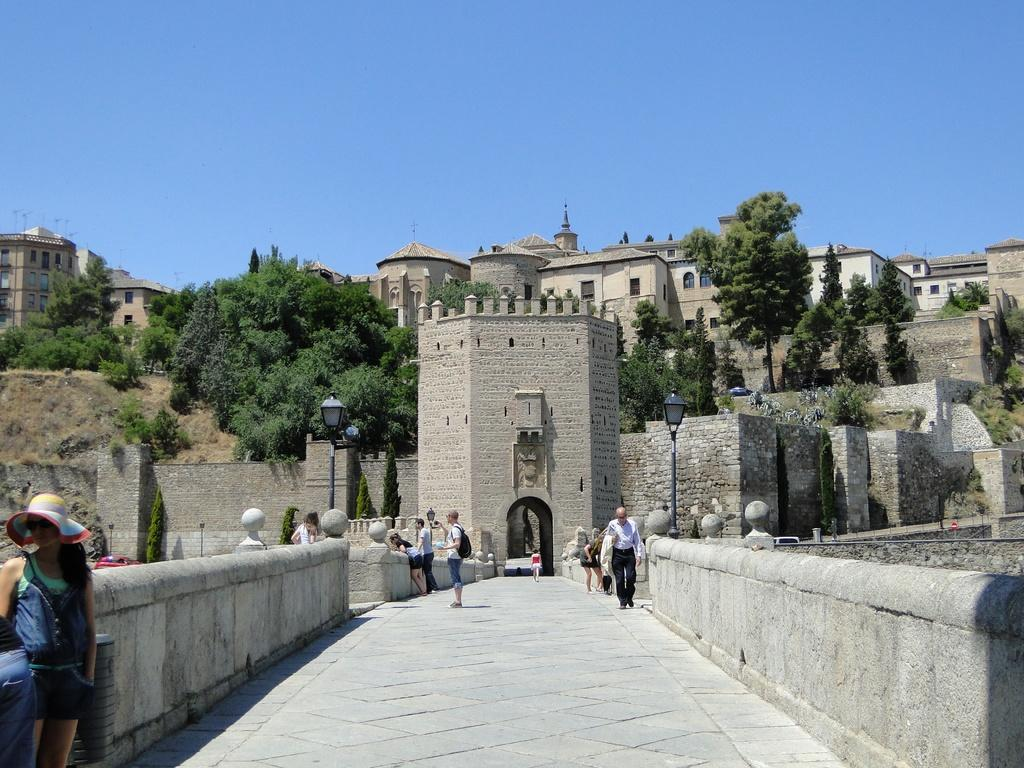Where was the image taken? The image was taken outside. What can be seen in the center of the image? There is a group of people in the center of the image. What is visible in the background of the image? There are buildings, trees, lights attached to poles, and the sky visible in the background of the image. What type of apparel is the friend wearing in the image? There is no friend present in the image, and therefore no apparel can be described. 